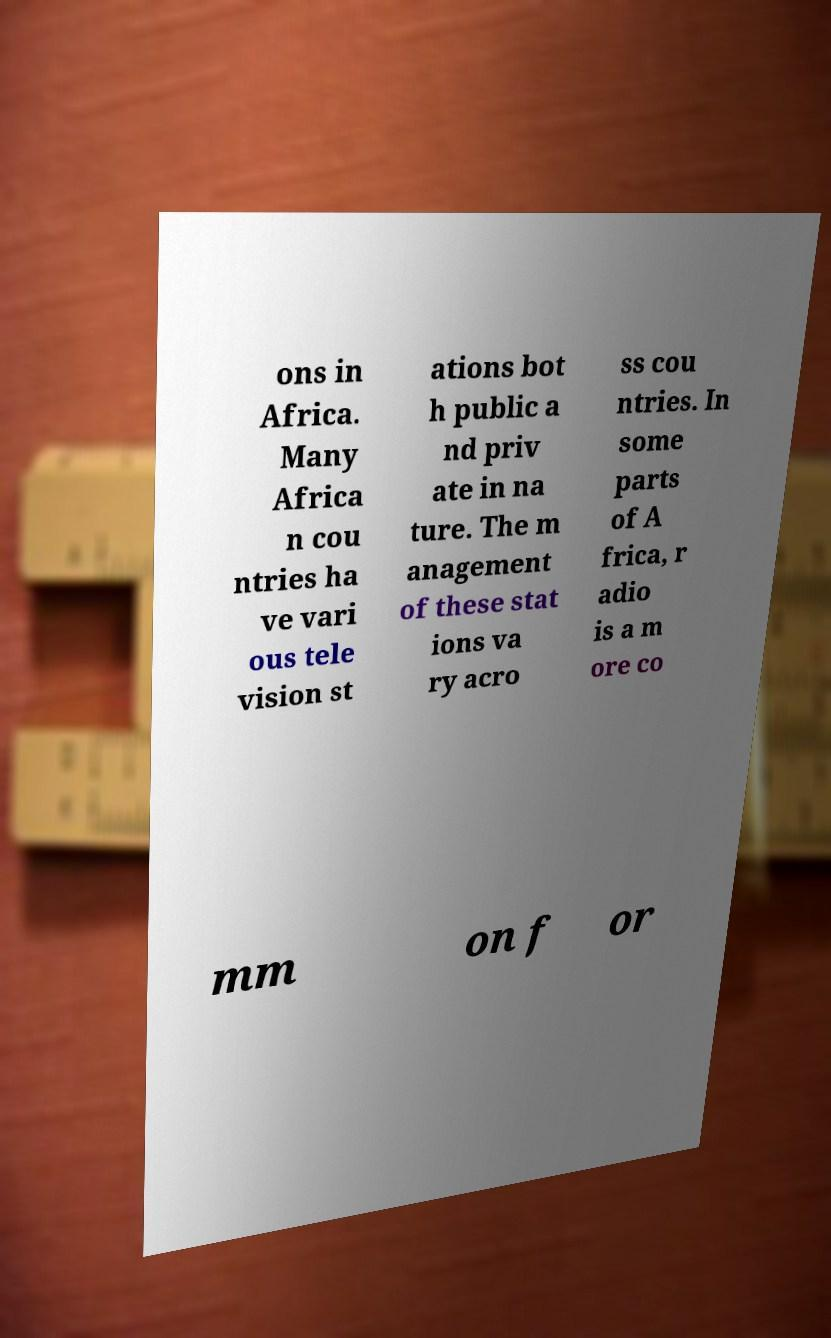There's text embedded in this image that I need extracted. Can you transcribe it verbatim? ons in Africa. Many Africa n cou ntries ha ve vari ous tele vision st ations bot h public a nd priv ate in na ture. The m anagement of these stat ions va ry acro ss cou ntries. In some parts of A frica, r adio is a m ore co mm on f or 